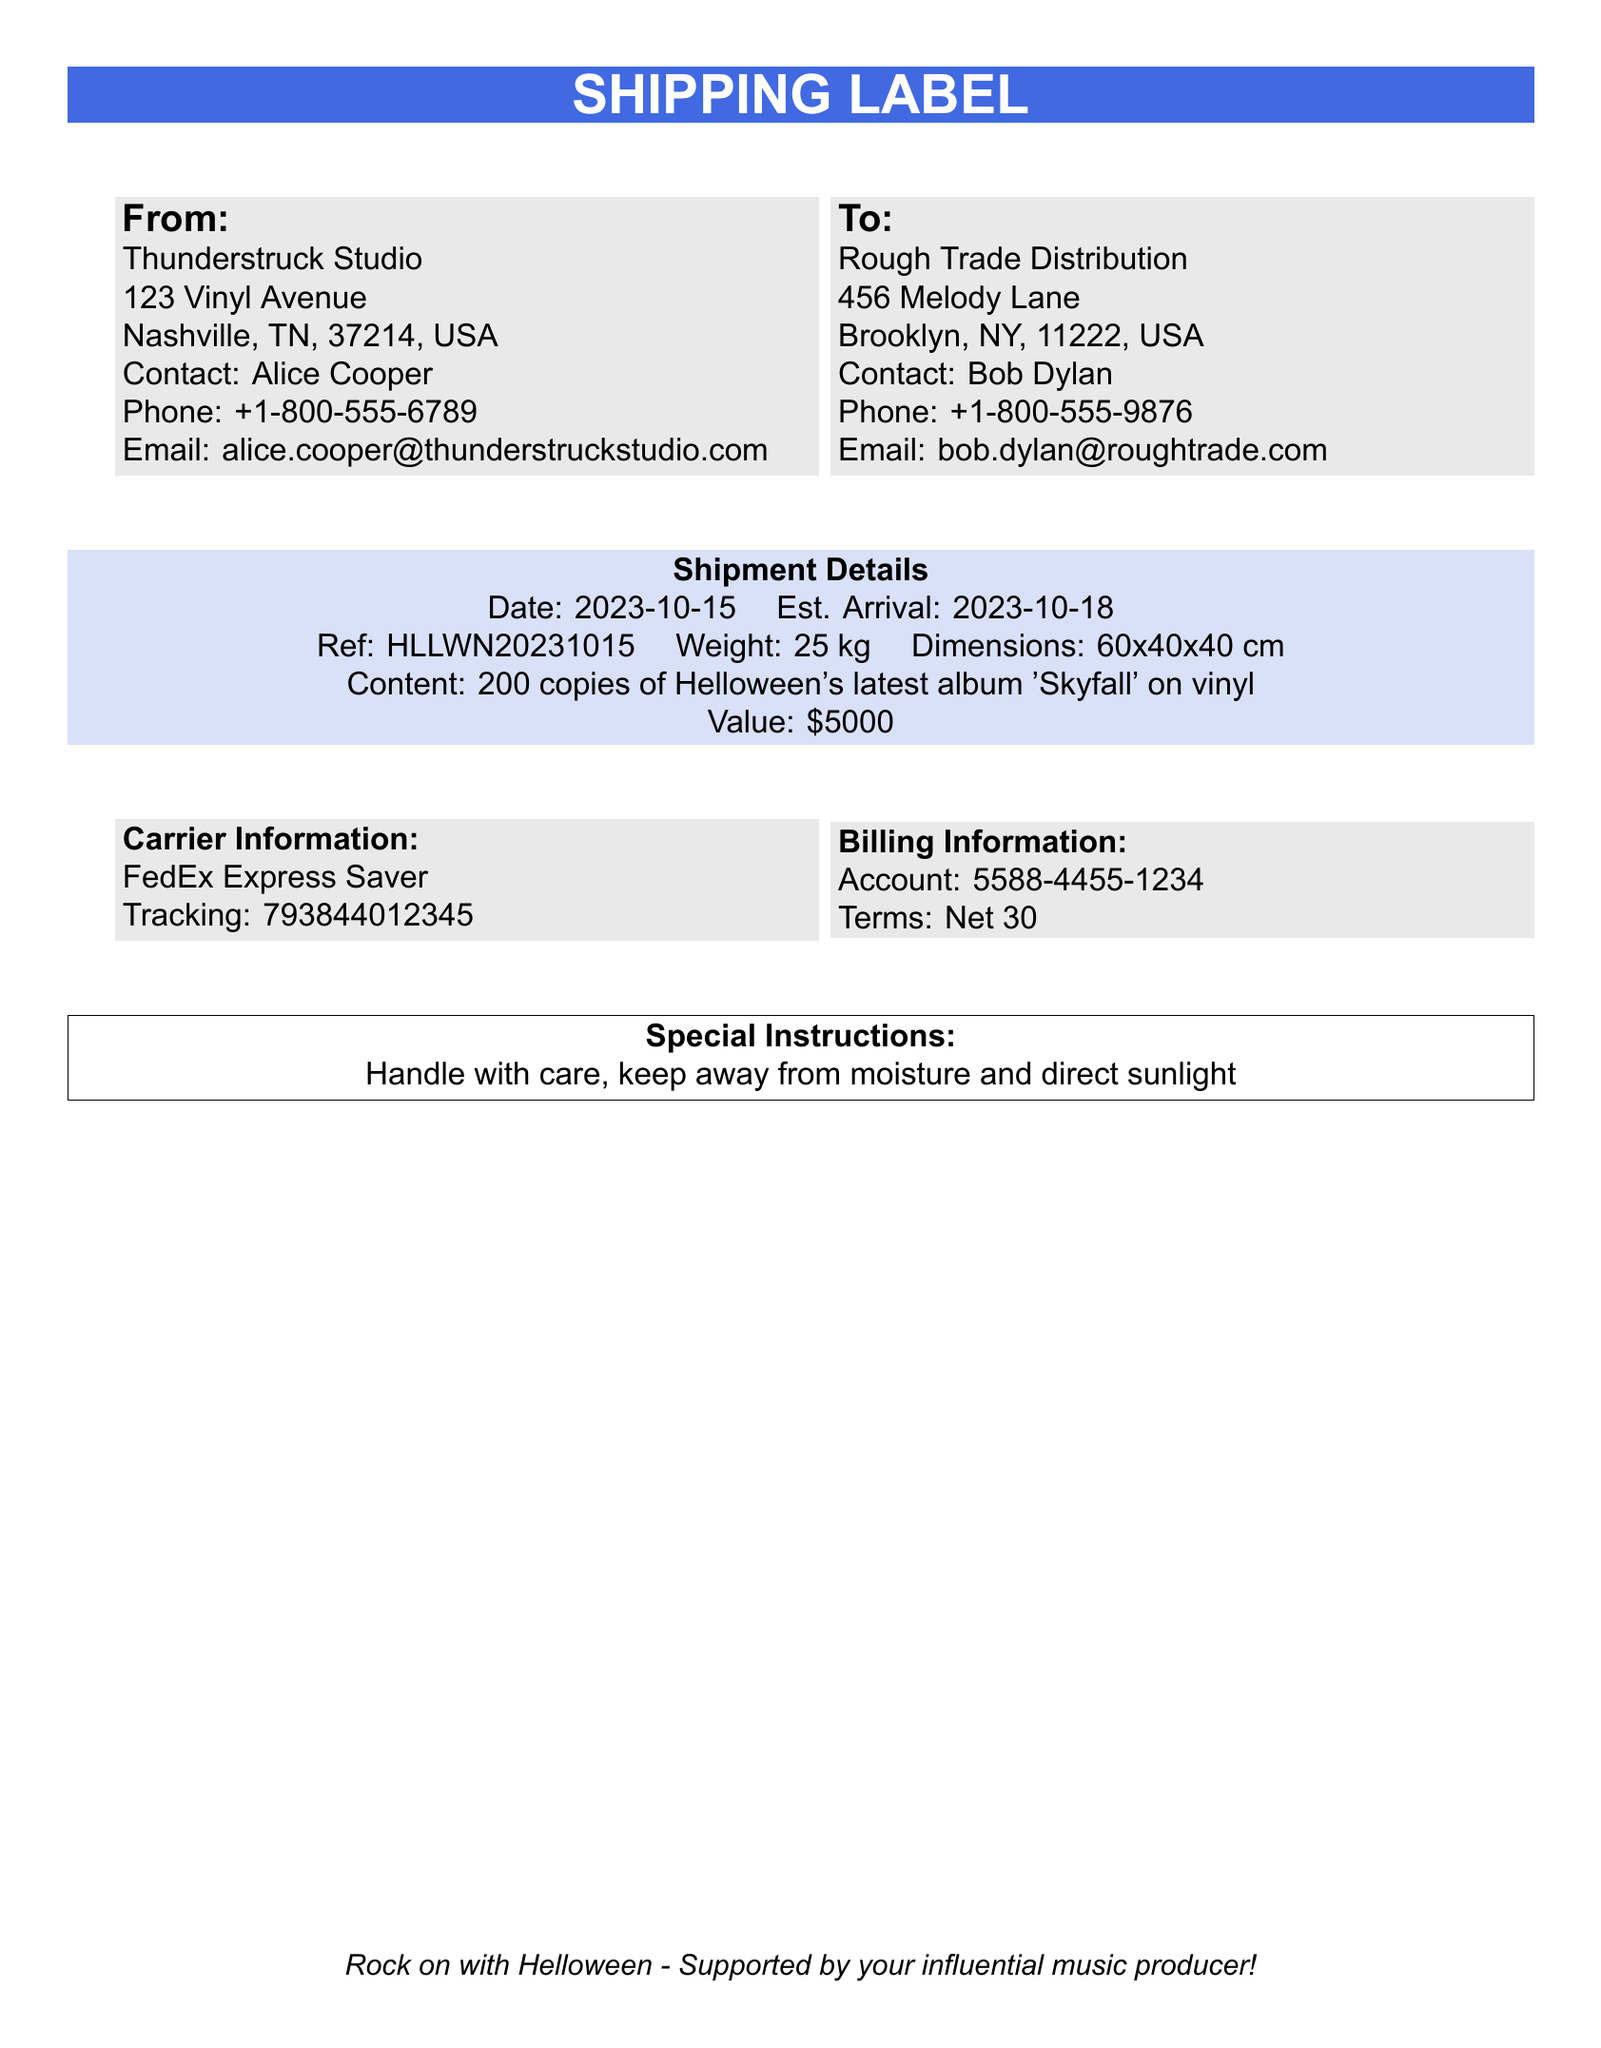what is the sender's name? The sender's name is listed in the "From" section of the document.
Answer: Alice Cooper what is the recipient's email? The recipient's email is found in the "To" section of the document.
Answer: bob.dylan@roughtrade.com what is the shipment date? The shipment date is mentioned in the "Shipment Details" section.
Answer: 2023-10-15 what is the estimated arrival date? The estimated arrival date is also found in the "Shipment Details" section.
Answer: 2023-10-18 how many vinyl copies are being shipped? The number of vinyl copies is specified in the "Content" section of the shipment details.
Answer: 200 copies what is the total weight of the shipment? The total weight is provided in the "Shipment Details" section of the document.
Answer: 25 kg what type of carrier is used for shipping? The type of carrier is mentioned in the "Carrier Information" section.
Answer: FedEx Express Saver what are the billing terms? The billing terms are stated in the "Billing Information" section of the document.
Answer: Net 30 what are the special instructions for handling the shipment? The special instructions are found in the dedicated section at the bottom of the document.
Answer: Handle with care, keep away from moisture and direct sunlight 